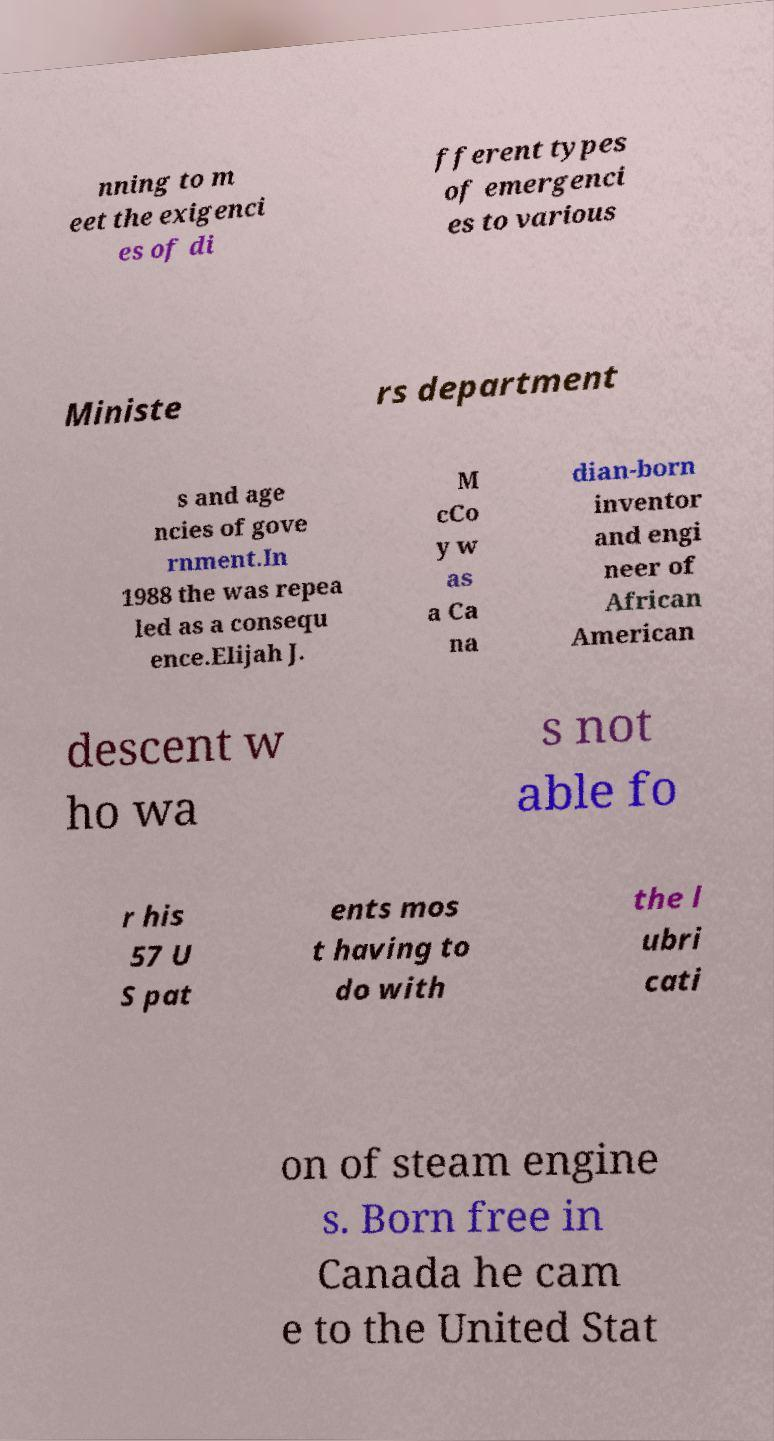Can you read and provide the text displayed in the image?This photo seems to have some interesting text. Can you extract and type it out for me? nning to m eet the exigenci es of di fferent types of emergenci es to various Ministe rs department s and age ncies of gove rnment.In 1988 the was repea led as a consequ ence.Elijah J. M cCo y w as a Ca na dian-born inventor and engi neer of African American descent w ho wa s not able fo r his 57 U S pat ents mos t having to do with the l ubri cati on of steam engine s. Born free in Canada he cam e to the United Stat 